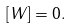Convert formula to latex. <formula><loc_0><loc_0><loc_500><loc_500>[ W ] = 0 .</formula> 